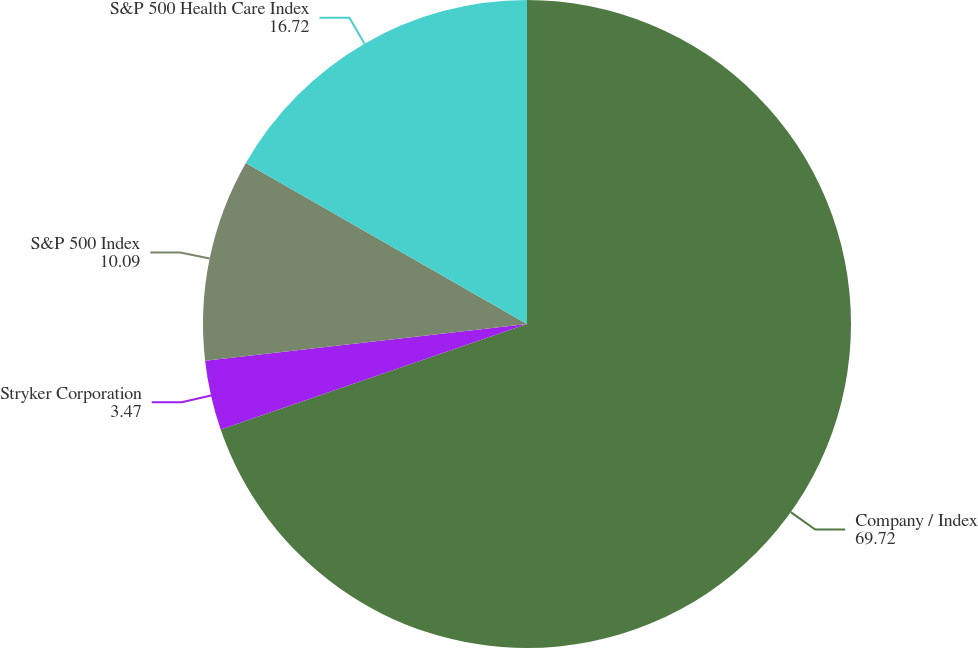Convert chart. <chart><loc_0><loc_0><loc_500><loc_500><pie_chart><fcel>Company / Index<fcel>Stryker Corporation<fcel>S&P 500 Index<fcel>S&P 500 Health Care Index<nl><fcel>69.72%<fcel>3.47%<fcel>10.09%<fcel>16.72%<nl></chart> 